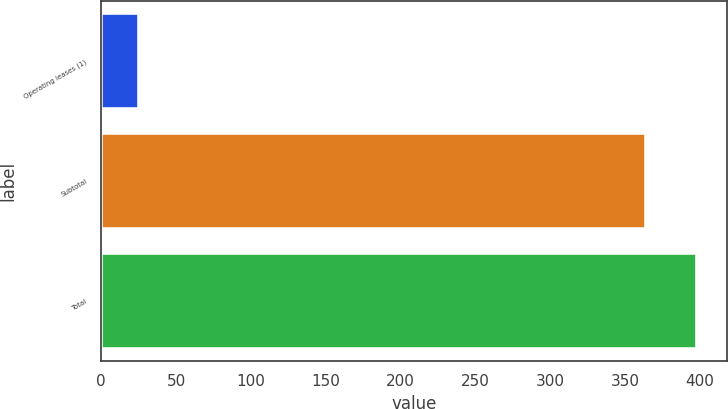Convert chart. <chart><loc_0><loc_0><loc_500><loc_500><bar_chart><fcel>Operating leases (1)<fcel>Subtotal<fcel>Total<nl><fcel>25<fcel>364<fcel>397.9<nl></chart> 